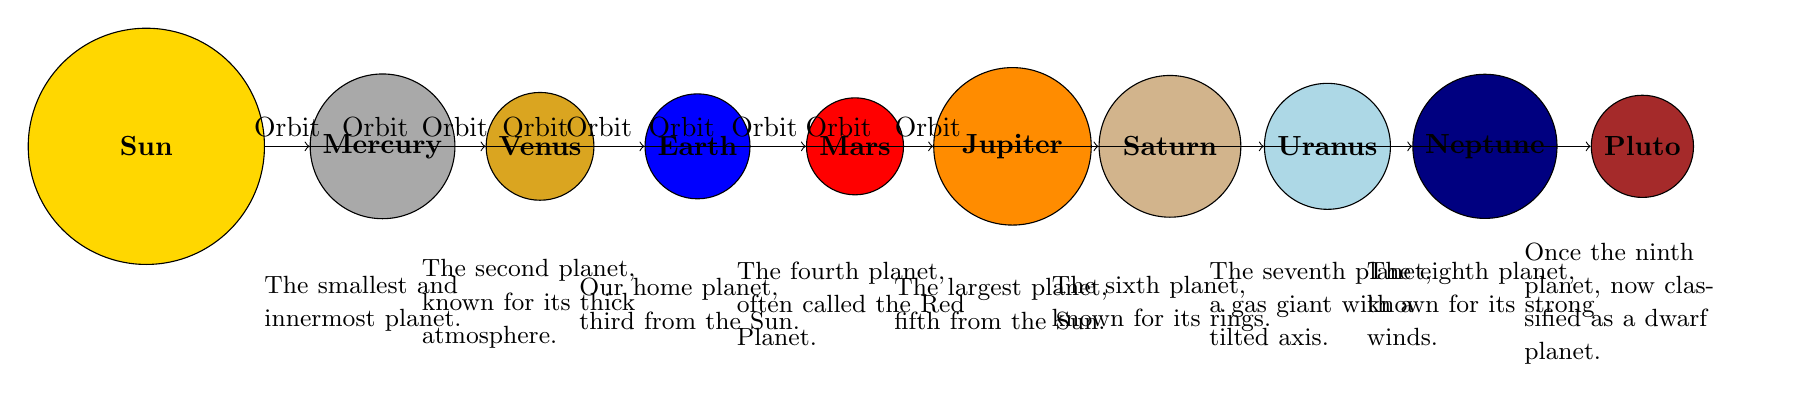What is the largest planet in the solar system? The diagram identifies Jupiter as the largest planet, as it is the fifth planet from the Sun, represented with the largest size compared to other celestial bodies in the diagram.
Answer: Jupiter How many gas giants are depicted in the diagram? The diagram illustrates four gas giants: Jupiter, Saturn, Uranus, and Neptune, which can be seen positioned at the right side, away from the Sun, and larger than terrestrial planets.
Answer: Four Which planet is known for its rings? The diagram specifically labels Saturn as the planet known for its rings, as indicated in the description below the corresponding circle.
Answer: Saturn What is the distance of Earth from the Sun in terms of order? Earth is the third planet from the Sun, as it is listed in the sequence of planets drawn in the diagram from the Sun outward.
Answer: Third Which celestial object is classified as a dwarf planet? According to the diagram, Pluto is the celestial object recognized as a dwarf planet, placed at the furthest position from the Sun in the diagram.
Answer: Pluto Which planet is referred to as the "Red Planet"? The diagram describes Mars as the "Red Planet," emphasizing its designation through the descriptive text positioned below the representation of Mars in the diagram.
Answer: Mars What color is used to represent Venus in the diagram? The diagram uses a golden color, specifically labelled as "Venus color," to fill the circle representing Venus, distinguishing it from the other planets.
Answer: Golden How many planets are illustrated in total in the solar system? The diagram contains a total of nine celestial objects including the Sun and planets, counted by identifying all the circles present in the diagram.
Answer: Nine 